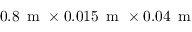Convert formula to latex. <formula><loc_0><loc_0><loc_500><loc_500>0 . 8 \, m \times 0 . 0 1 5 \, m \times 0 . 0 4 \, m</formula> 